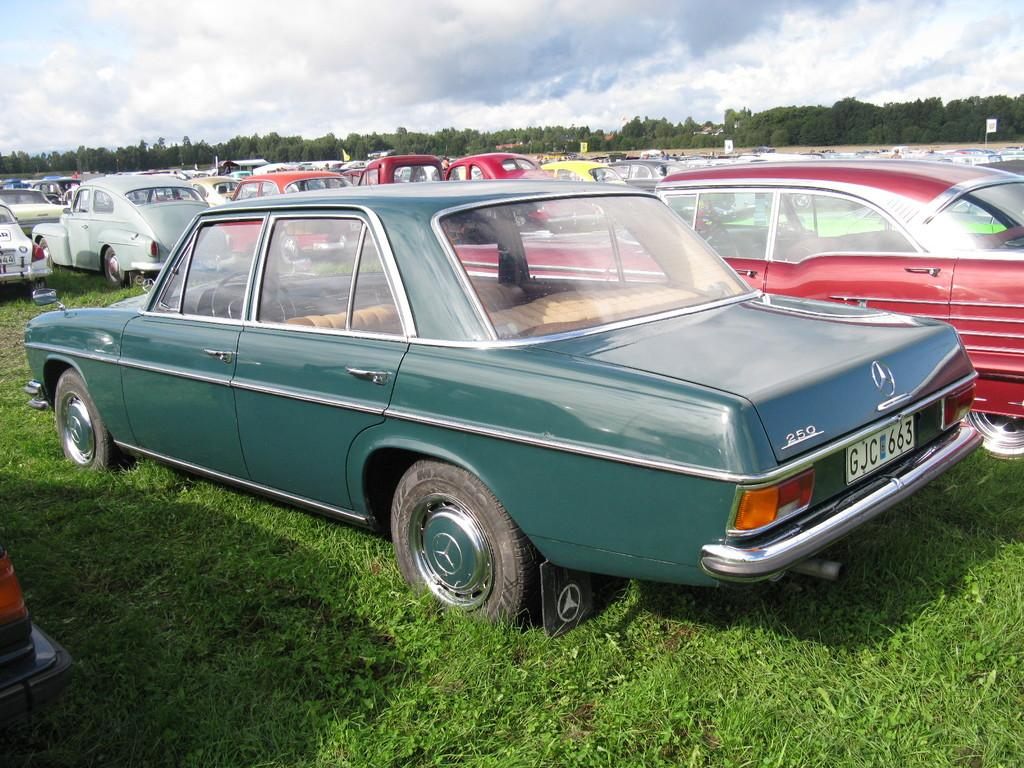What is the main subject of the image? The main subject of the image is many cars on the grassland. What can be seen in the background of the image? There are trees in the background of the image. What is visible above the grassland and trees? The sky is visible in the image. What is present in the sky? Clouds are present in the sky. What type of cast can be seen on the grassland in the image? There is no cast present in the image; it features cars on the grassland. What appliance is being used by the cars in the image? Cars do not use appliances; they are vehicles powered by engines. 